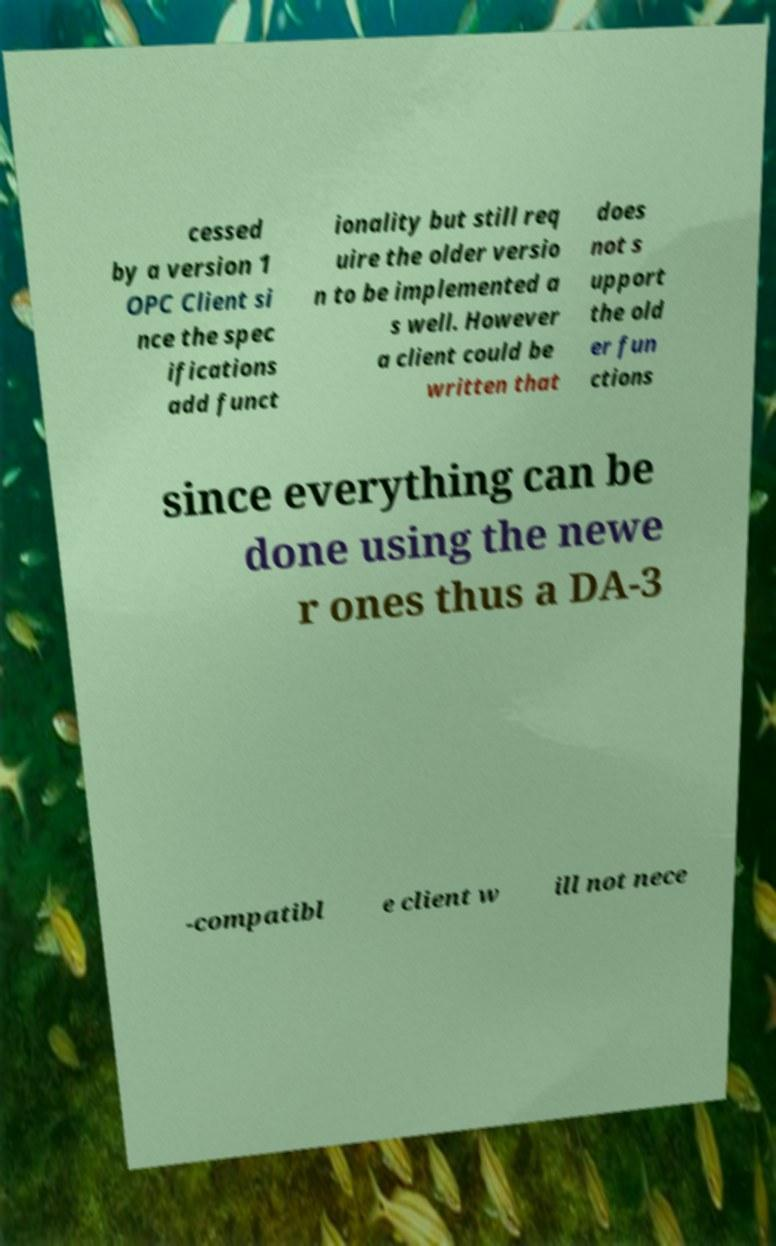What messages or text are displayed in this image? I need them in a readable, typed format. cessed by a version 1 OPC Client si nce the spec ifications add funct ionality but still req uire the older versio n to be implemented a s well. However a client could be written that does not s upport the old er fun ctions since everything can be done using the newe r ones thus a DA-3 -compatibl e client w ill not nece 